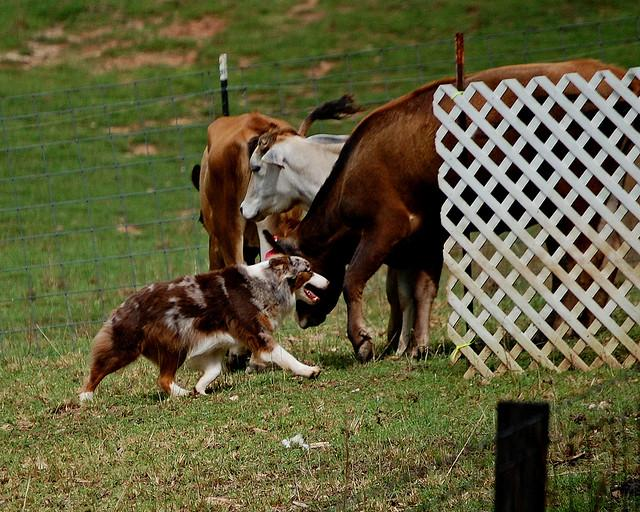What is a male of the larger animals called?

Choices:
A) drake
B) bull
C) dog
D) ram bull 